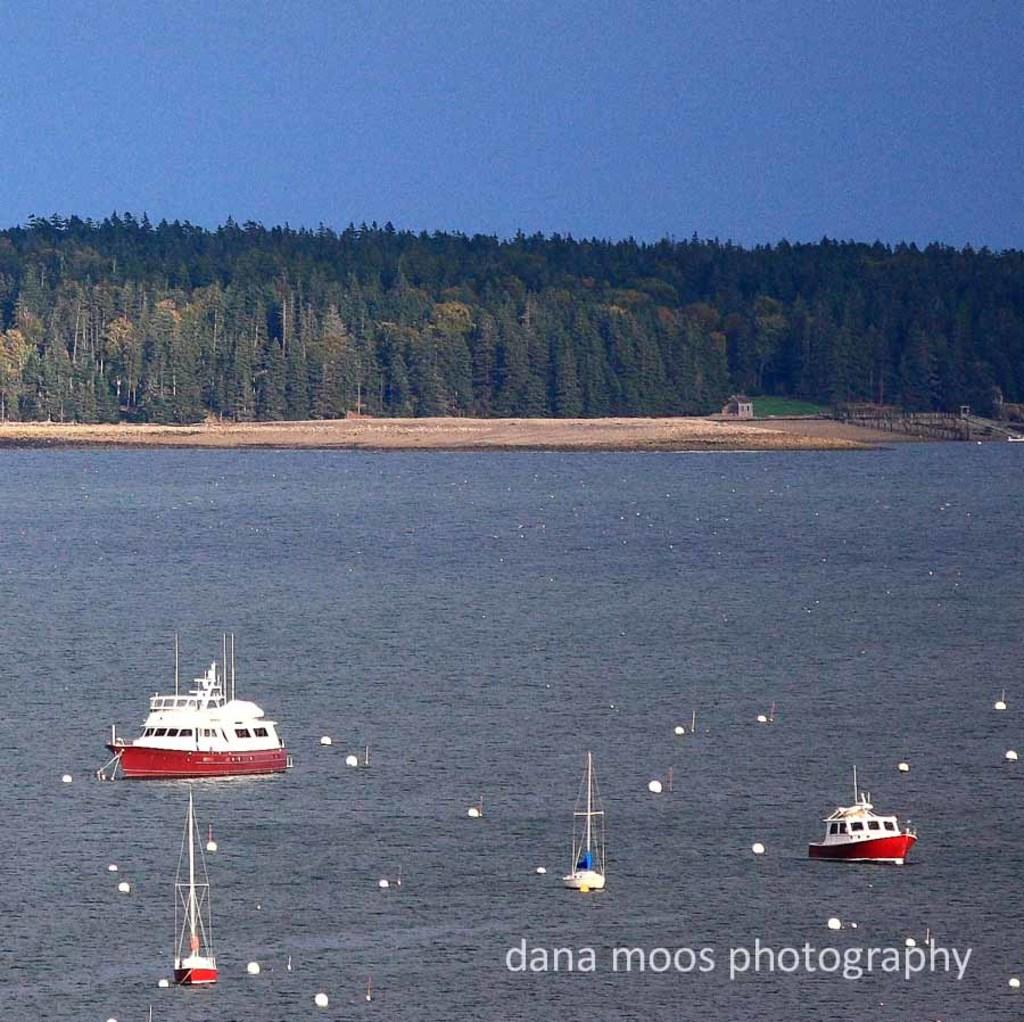<image>
Provide a brief description of the given image. A outdoor seen and the print of dana moos photography. 